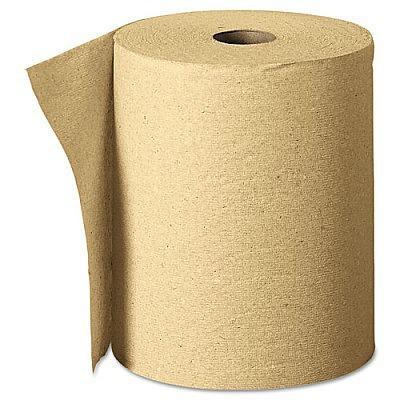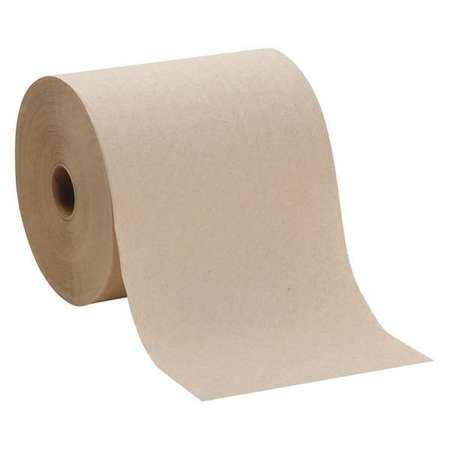The first image is the image on the left, the second image is the image on the right. For the images displayed, is the sentence "There is at least one roll of brown paper in the image on the left." factually correct? Answer yes or no. Yes. The first image is the image on the left, the second image is the image on the right. Analyze the images presented: Is the assertion "Both paper rolls and paper towel stacks are shown." valid? Answer yes or no. No. 